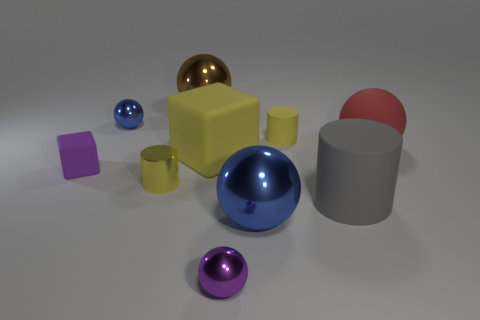Subtract 1 balls. How many balls are left? 4 Subtract all tiny purple shiny spheres. How many spheres are left? 4 Subtract all brown spheres. How many spheres are left? 4 Subtract all yellow spheres. Subtract all brown cylinders. How many spheres are left? 5 Subtract all cylinders. How many objects are left? 7 Subtract all large rubber spheres. Subtract all large spheres. How many objects are left? 6 Add 3 purple objects. How many purple objects are left? 5 Add 1 tiny brown shiny things. How many tiny brown shiny things exist? 1 Subtract 0 purple cylinders. How many objects are left? 10 